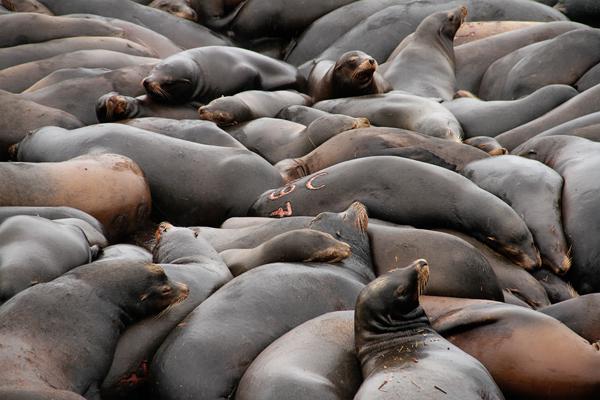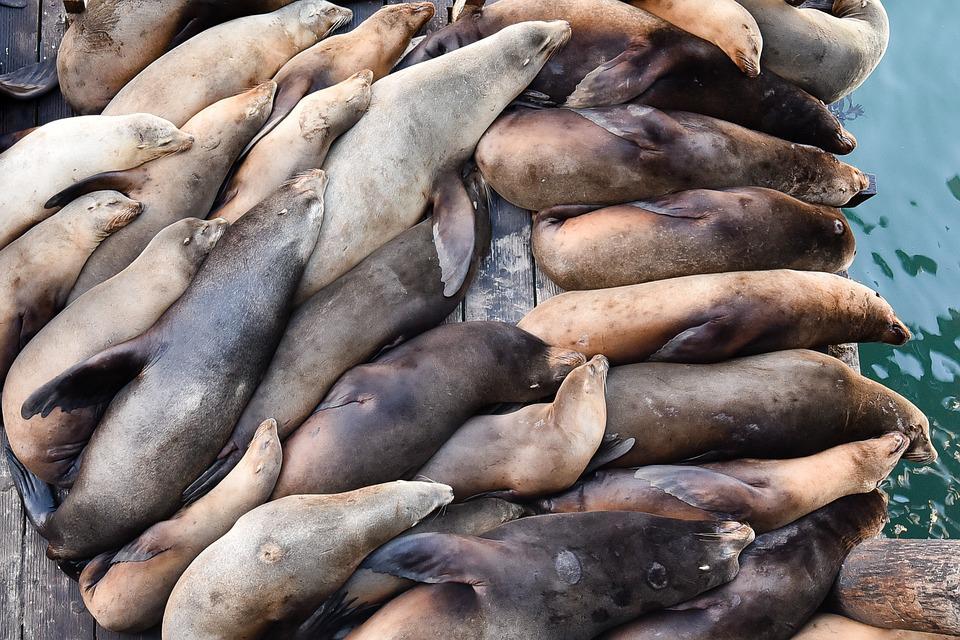The first image is the image on the left, the second image is the image on the right. Analyze the images presented: Is the assertion "There are less than ten sea mammals sunning in the image on the right." valid? Answer yes or no. No. 